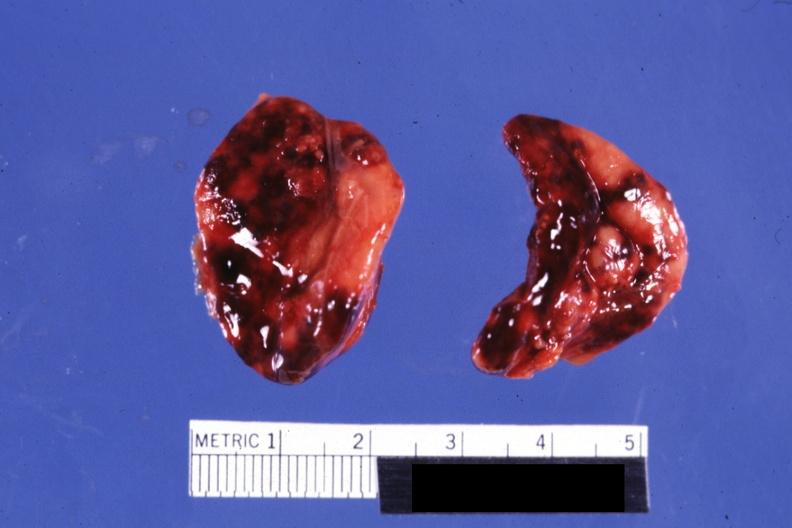what is present?
Answer the question using a single word or phrase. Hemorrhage newborn 